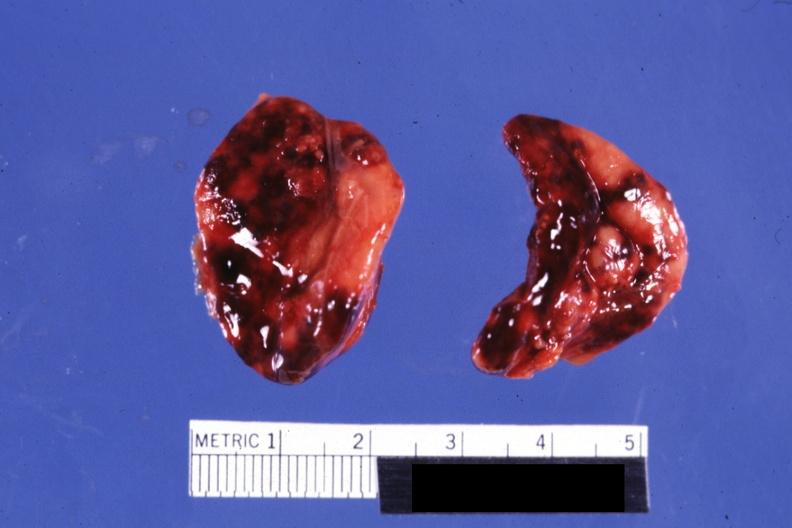what is present?
Answer the question using a single word or phrase. Hemorrhage newborn 